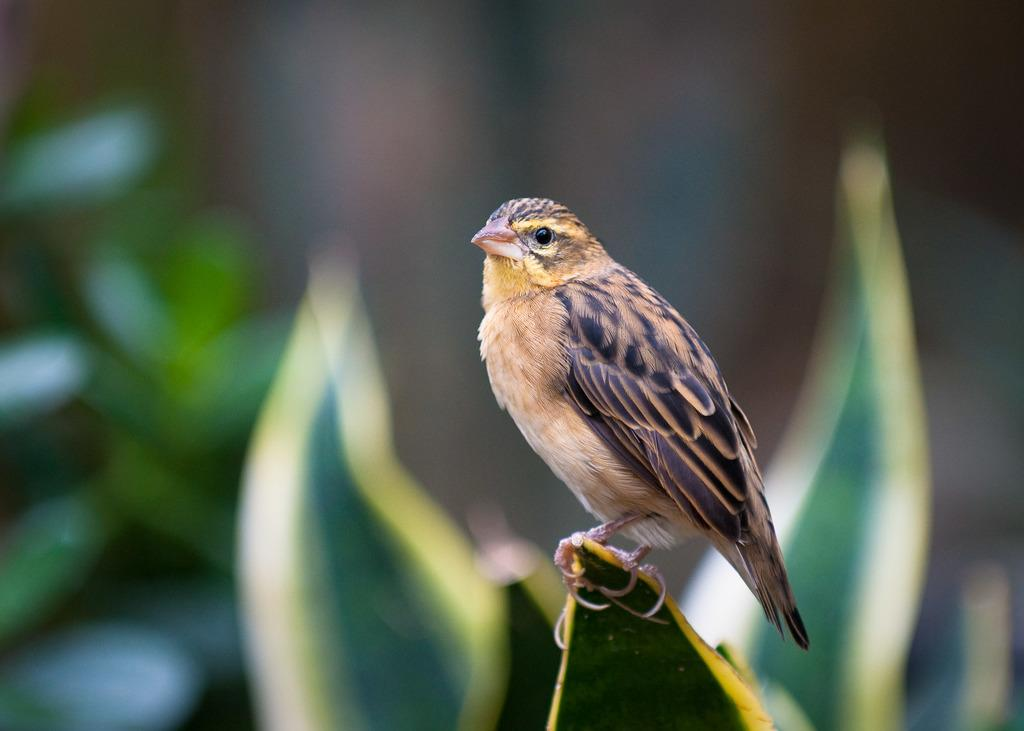What type of animal is in the image? There is a bird in the image. Where is the bird located? The bird is on a leaf. Can you describe the background of the image? The background of the image is blurry. What language does the bird speak in the image? Birds do not speak human languages, so it is not possible to determine the language the bird speaks in the image. 